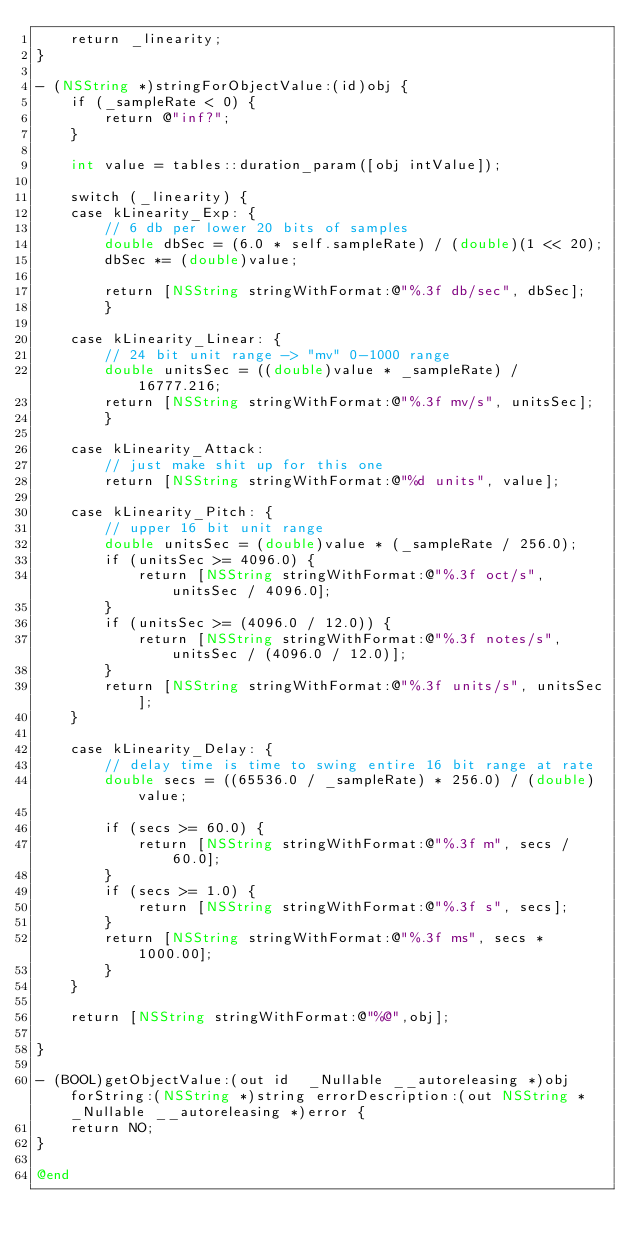<code> <loc_0><loc_0><loc_500><loc_500><_ObjectiveC_>    return _linearity;
}

- (NSString *)stringForObjectValue:(id)obj {
    if (_sampleRate < 0) {
        return @"inf?";
    }

    int value = tables::duration_param([obj intValue]);

    switch (_linearity) {
    case kLinearity_Exp: {
        // 6 db per lower 20 bits of samples
        double dbSec = (6.0 * self.sampleRate) / (double)(1 << 20);
        dbSec *= (double)value;

        return [NSString stringWithFormat:@"%.3f db/sec", dbSec];
        }

    case kLinearity_Linear: {
        // 24 bit unit range -> "mv" 0-1000 range
        double unitsSec = ((double)value * _sampleRate) / 16777.216;
        return [NSString stringWithFormat:@"%.3f mv/s", unitsSec];
        }

    case kLinearity_Attack:
        // just make shit up for this one
        return [NSString stringWithFormat:@"%d units", value];

    case kLinearity_Pitch: {
        // upper 16 bit unit range
        double unitsSec = (double)value * (_sampleRate / 256.0);
        if (unitsSec >= 4096.0) {
            return [NSString stringWithFormat:@"%.3f oct/s", unitsSec / 4096.0];
        }
        if (unitsSec >= (4096.0 / 12.0)) {
            return [NSString stringWithFormat:@"%.3f notes/s", unitsSec / (4096.0 / 12.0)];
        }
        return [NSString stringWithFormat:@"%.3f units/s", unitsSec];
    }

    case kLinearity_Delay: {
        // delay time is time to swing entire 16 bit range at rate
        double secs = ((65536.0 / _sampleRate) * 256.0) / (double)value;

        if (secs >= 60.0) {
            return [NSString stringWithFormat:@"%.3f m", secs / 60.0];
        }
        if (secs >= 1.0) {
            return [NSString stringWithFormat:@"%.3f s", secs];
        }
        return [NSString stringWithFormat:@"%.3f ms", secs * 1000.00];
        }
    }

    return [NSString stringWithFormat:@"%@",obj];

}

- (BOOL)getObjectValue:(out id  _Nullable __autoreleasing *)obj forString:(NSString *)string errorDescription:(out NSString * _Nullable __autoreleasing *)error {
    return NO;
}

@end
</code> 